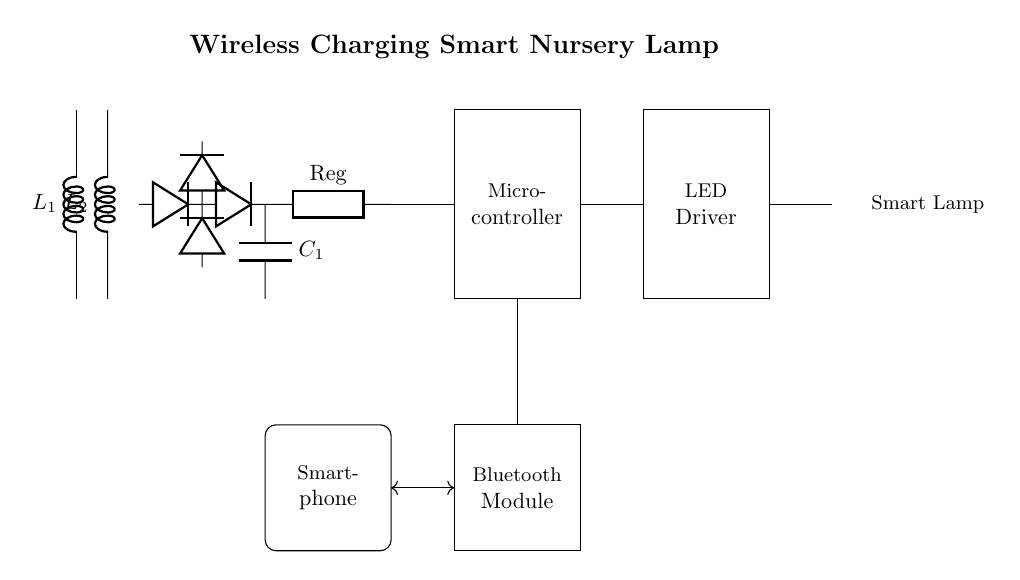What type of coil is used for wireless charging? The circuit diagram shows two inductors labeled L1 and L2. Inductors are used in wireless charging circuits to create a magnetic field for energy transfer.
Answer: Inductor What is the role of the LED in this circuit? The LED is part of the smart lamp, which is intended to provide light when controlled via the smartphone. It's connected to the LED driver, which regulates the current for proper operation.
Answer: Light source How many diodes are there in the rectifier section? The diagram shows a total of four diodes arranged in the rectifier section, which is used to convert AC voltage to DC voltage necessary for powering the microcontroller and other components.
Answer: Four What component serves as the main controller for the lamp? The microcontroller is identified within the circuit diagram and serves as the main component that controls the lamp's operation based on signals received from the smartphone via Bluetooth.
Answer: Microcontroller What is the purpose of the smoothing capacitor? The smoothing capacitor, labeled C1, is used to reduce voltage fluctuations in the rectified output, providing a more stable DC voltage to the microcontroller and ensuring reliable operation of the lamp.
Answer: Voltage stabilization What connects the smartphone to the wireless charging circuit? The connection between the smartphone and the wireless charging circuit is facilitated through a bidirectional line shown in the diagram, allowing communication and control signals to pass between the two.
Answer: Bidirectional line 